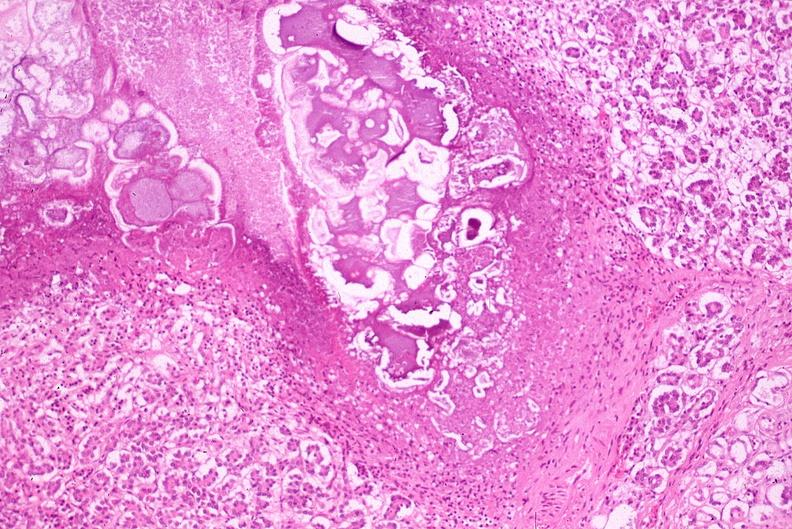does beckwith-wiedemann syndrome show pancreatic fat necrosis?
Answer the question using a single word or phrase. No 